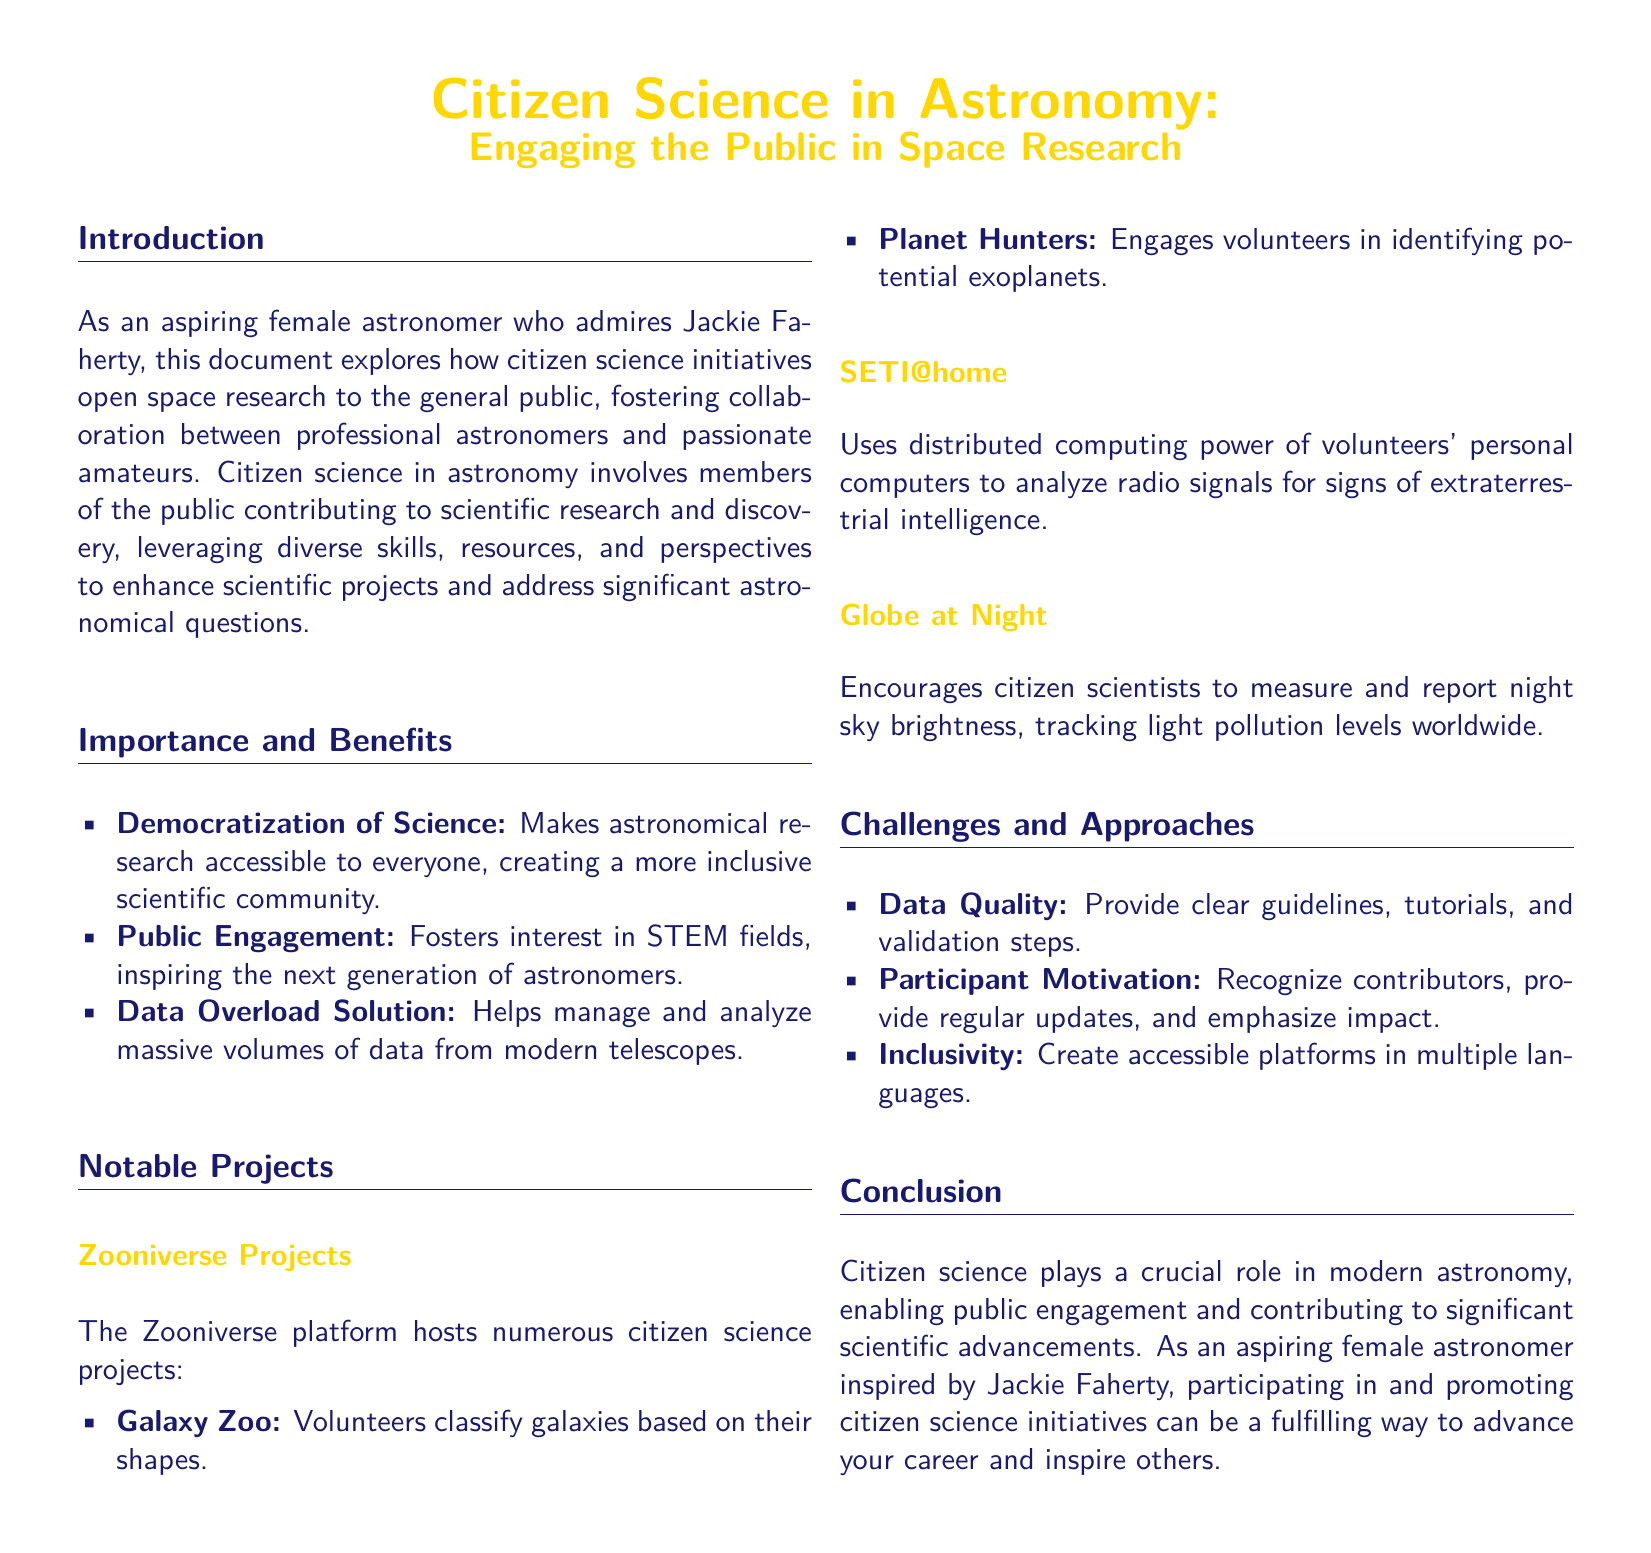what is the title of the whitepaper? The title of the whitepaper is given at the beginning and highlights the focus on citizen science.
Answer: Citizen Science in Astronomy: Engaging the Public in Space Research what is the name of the platform that hosts numerous citizen science projects? The document mentions a platform that is well-known for hosting citizen science projects, particularly in astronomy.
Answer: Zooniverse which project allows volunteers to classify galaxies? The document lists various projects on the Zooniverse platform, specifically mentioning one that involves classifying galaxies.
Answer: Galaxy Zoo what is one of the benefits of citizen science in astronomy? The document outlines multiple benefits of citizen science, focusing on accessibility and engagement.
Answer: Democratization of Science what challenge relates to the quality of data collected through citizen science? The document identifies various challenges faced in citizen science, including quality issues that require attention.
Answer: Data Quality how does citizen science inspire future generations? The document refers to how citizen science initiatives help engage the public and promote interest in STEM fields.
Answer: Public Engagement what is the purpose of the Globe at Night project? The document describes the Globe at Night project, which focuses on a specific citizen science initiative.
Answer: Measure and report night sky brightness what should be provided to enhance data quality in citizen science? The document suggests specific strategies to address challenges in citizen science related to data quality.
Answer: Clear guidelines what motivates participants to contribute to citizen science projects? The document mentions several factors that can influence participants' motivation to engage with citizen science.
Answer: Recognize contributors 